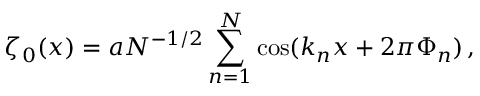Convert formula to latex. <formula><loc_0><loc_0><loc_500><loc_500>\zeta _ { 0 } ( x ) = a N ^ { - 1 / 2 } \sum _ { n = 1 } ^ { N } \cos ( k _ { n } x + 2 \pi \Phi _ { n } ) \, ,</formula> 